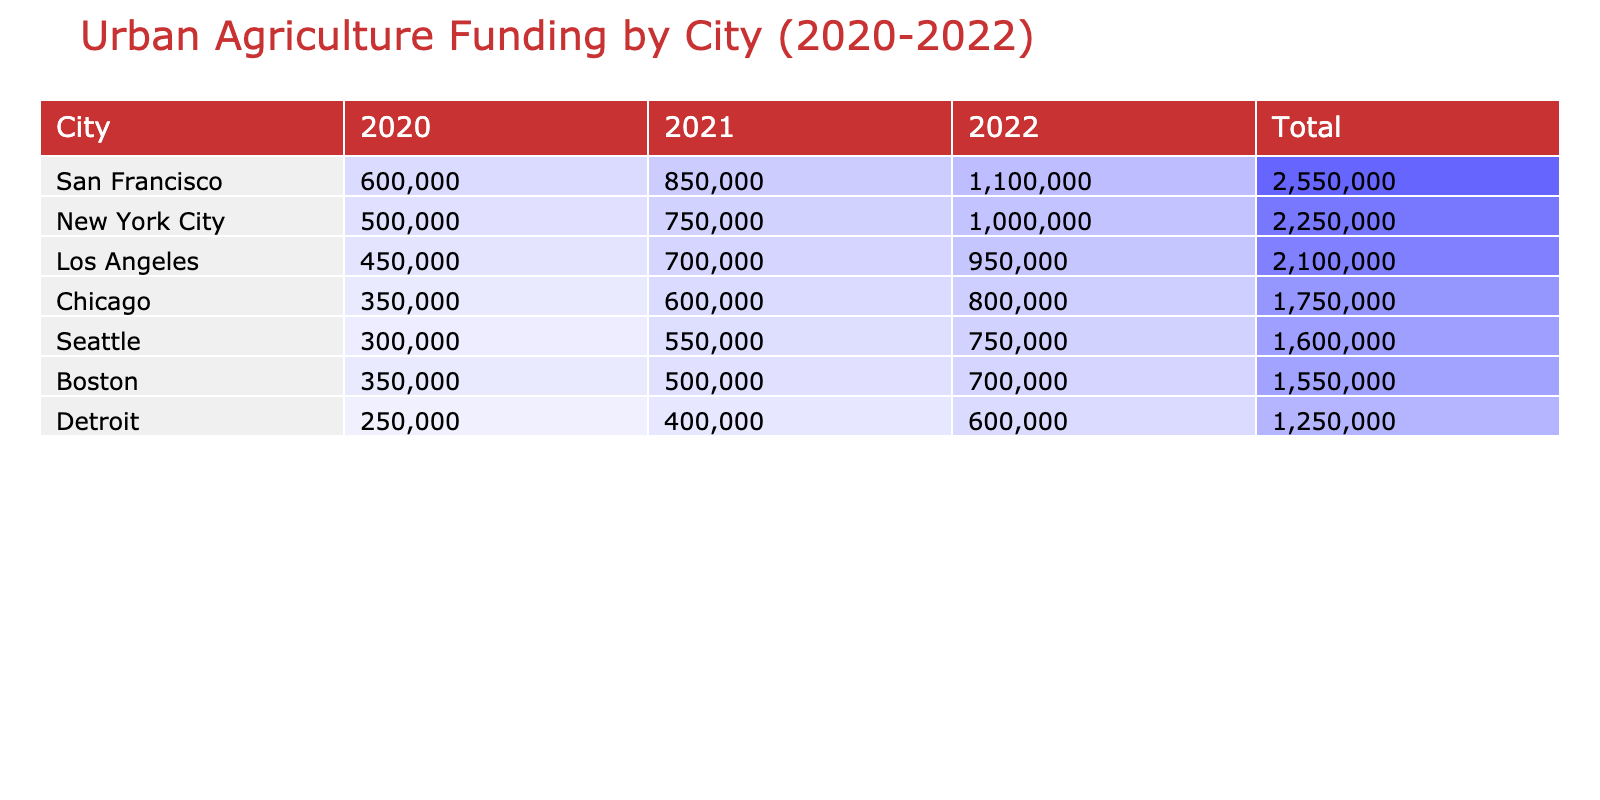What city received the highest funding in 2022? In the table, we look at the funding amounts for each city in the year 2022. New York City received 1,000,000 dollars, which is higher than the amounts received by all other cities.
Answer: New York City What was the total funding for urban agriculture initiatives in Los Angeles from 2020 to 2022? To find the total funding for Los Angeles, we sum the amounts for each year: 450,000 (2020) + 700,000 (2021) + 950,000 (2022) = 2,100,000 dollars.
Answer: 2,100,000 Did Detroit receive more funding in 2021 compared to 2020? In 2020, Detroit received 250,000 dollars, whereas in 2021, it received 400,000 dollars. Since 400,000 is more than 250,000, the statement is true.
Answer: Yes Which city had the most beneficiaries in its urban agriculture initiatives in 2020? For the year 2020, we can check the beneficiaries listed for each city: New York City had 5,000, Chicago had 3,000, Los Angeles had 7,500, Seattle had 4,000, Detroit had 800, and Boston had 2,500. Los Angeles had the highest number, with 7,500 beneficiaries.
Answer: Los Angeles What was the average funding amount for Chicago over the three years? We take the funding amounts for Chicago from each year: 350,000 (2020) + 600,000 (2021) + 800,000 (2022) = 1,750,000. There are 3 years of funding, so we divide by 3: 1,750,000 / 3 = approximately 583,333.
Answer: 583,333 